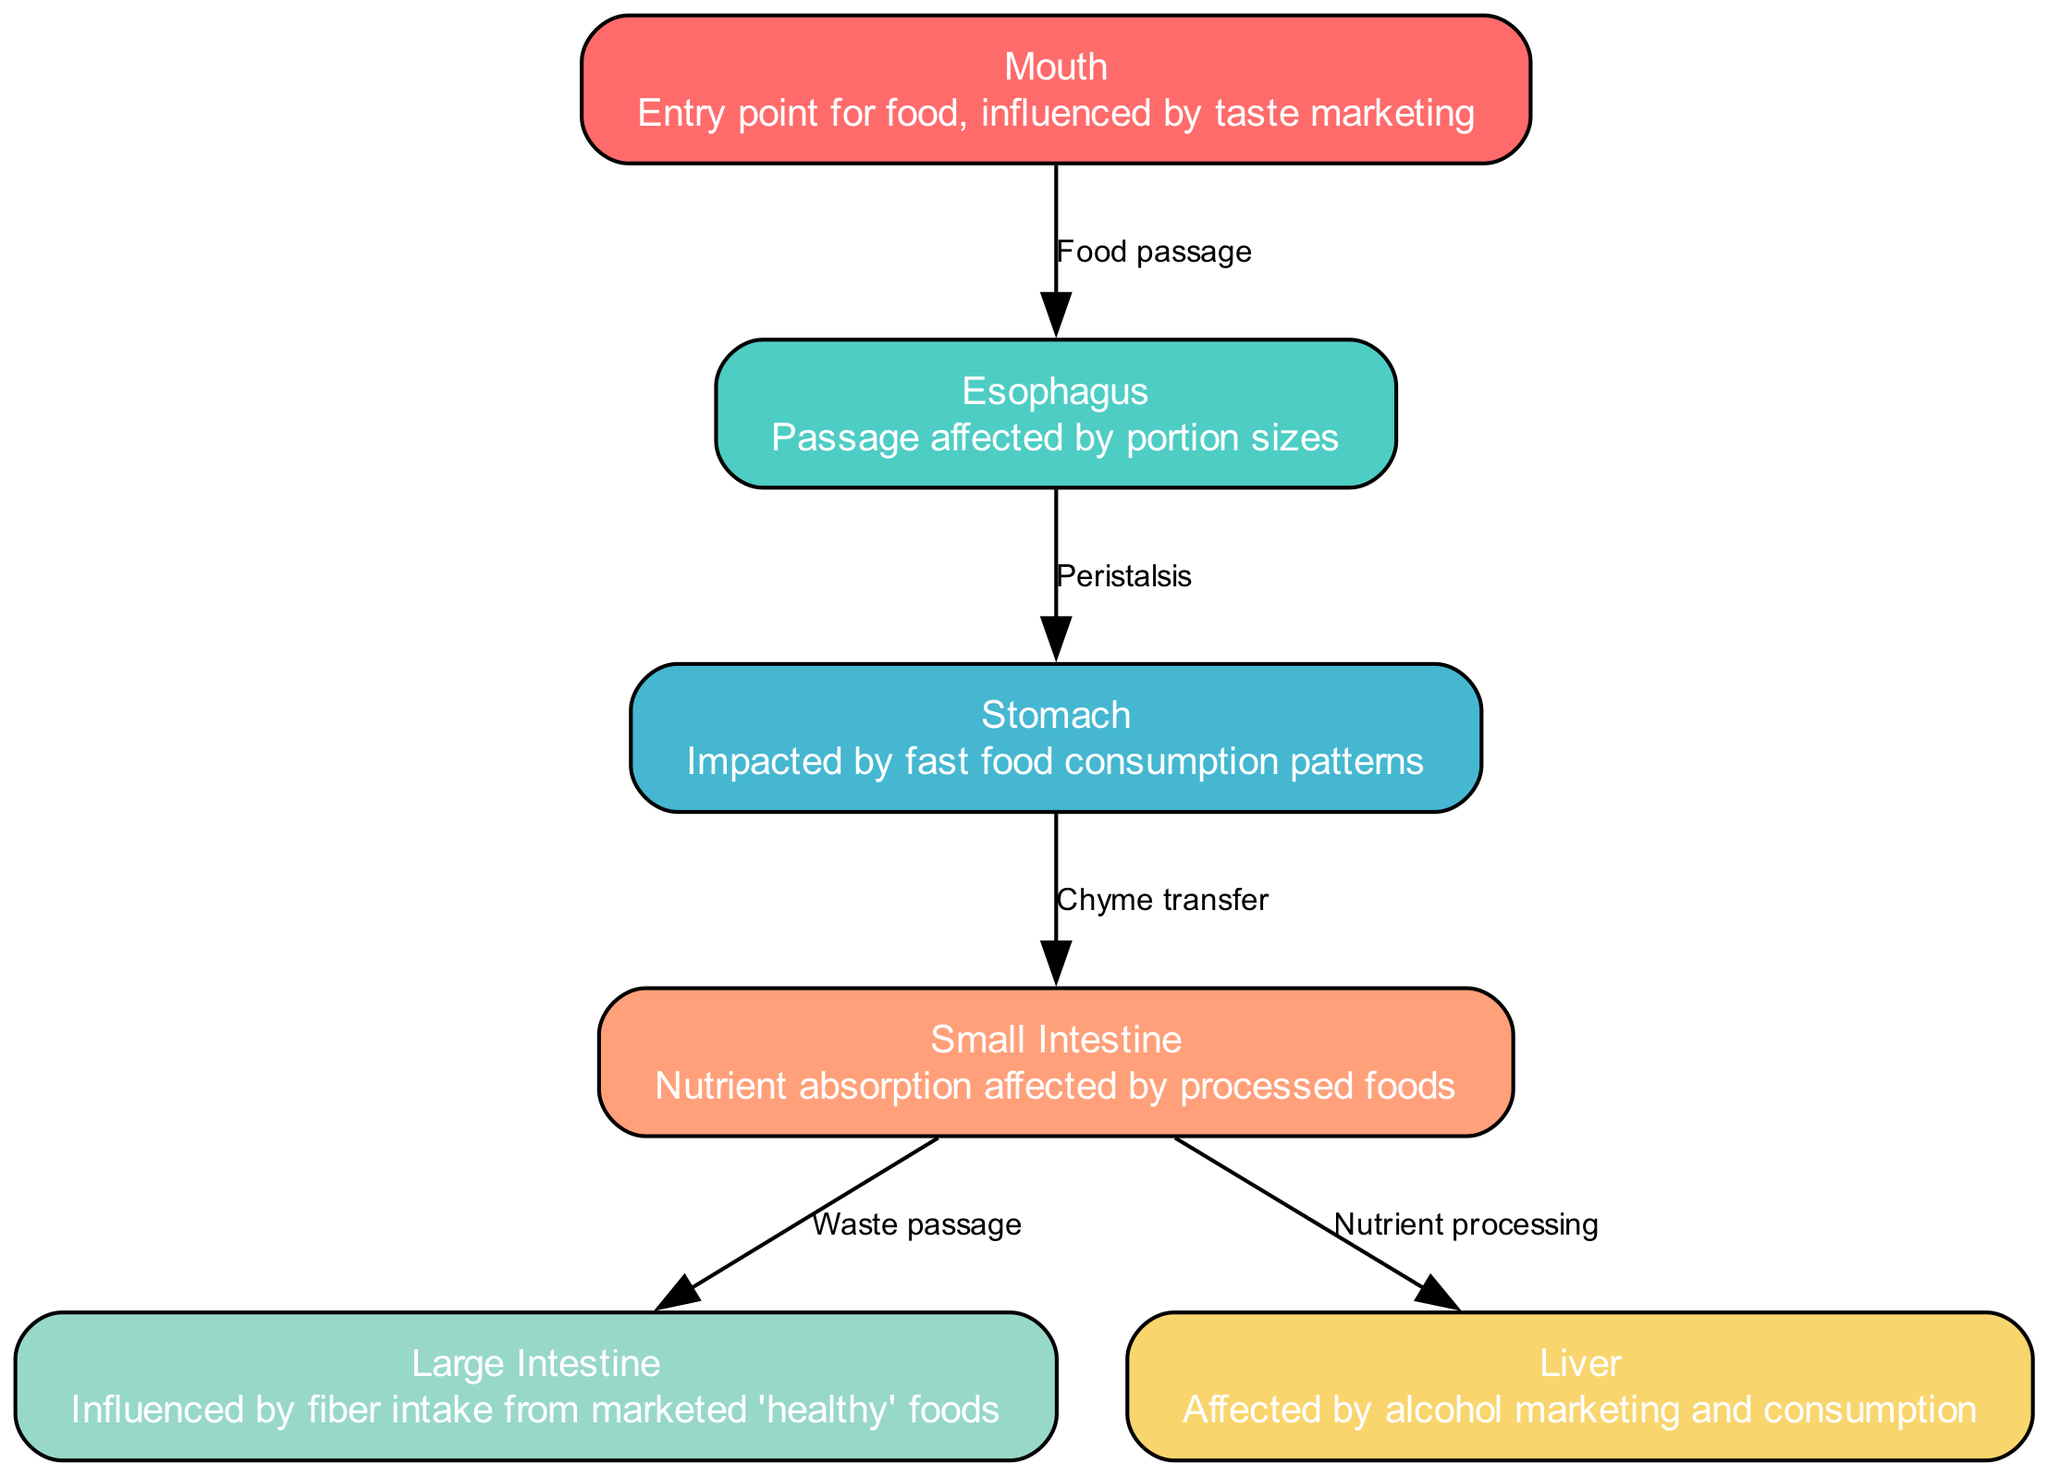What is the entry point for food in the digestive system? The diagram indicates that the "Mouth" is the entry point for food, as labeled in the node description.
Answer: Mouth How many nodes are present in the digestive system diagram? By counting the nodes listed in the diagram data, we can see there are six nodes: Mouth, Esophagus, Stomach, Small Intestine, Large Intestine, and Liver.
Answer: 6 What passage is affected by portion sizes? The passage between the mouth and stomach is referred to as the "Esophagus", which is noted to be affected by portion sizes based on the node description.
Answer: Esophagus Which organ is impacted by fast food consumption patterns? The diagram identifies the "Stomach" as impacted by fast food consumption patterns in its description, making it clear which organ is affected.
Answer: Stomach Which area absorbs nutrients influenced by processed foods? The "Small Intestine" is described as the area where nutrient absorption occurs, pointing to processed foods as a factor that influences this process.
Answer: Small Intestine From which area does waste pass to the large intestine? The edge between the "Small Intestine" and "Large Intestine" indicates that this is the passage for waste, as labeled in the diagram for "Waste passage".
Answer: Small Intestine What question does the liver's function relate to in the context of this diagram? The "Liver" processes nutrients from the Small Intestine, and the influence of alcohol marketing is noted, showing a connection between liver function and consumption patterns.
Answer: Nutrient processing How many edges are there in the digestive system diagram? The edges represent the relationships between the nodes. By reviewing, we see there are five edges connecting the various parts of the digestive system.
Answer: 5 Which area is affected by fiber intake from marketed 'healthy' foods? As per the node description, the "Large Intestine" is specifically noted to be influenced by fiber intake from foods that are marketed as healthy, answering the question directly.
Answer: Large Intestine 